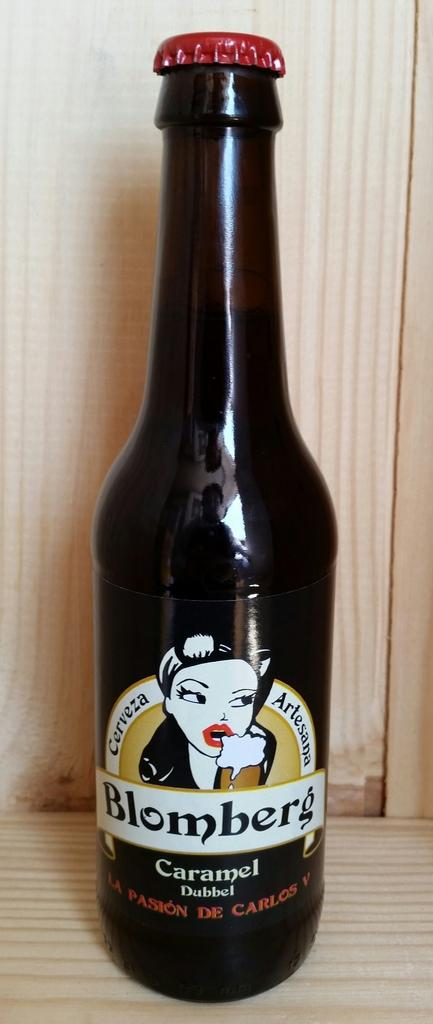Provide a one-sentence caption for the provided image. A brown bottle of Blomberg Carmel Dubbel, a kind of beer. 